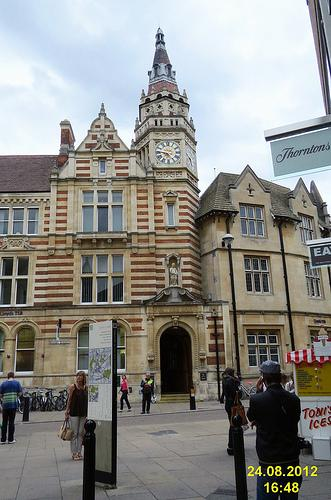What type of information would someone find on the map displayed on the sidewalk? The map offers explanations for tourists and directions around the town, helping them navigate and find various points of interest. What types of signs, stands, or kiosks can you identify in the image, and what are their characteristics? There is a red and white ice cream stand, a yellow time and date stamp, a sign giving directions around town, a kiosk selling assorted ices, and a sign advertising Thorntons in the image. Describe the scene on the sidewalk in front of the striped building, focusing on the people and their interactions. People are walking on the sidewalk, with a woman carrying a handbag, a man talking on a cell phone, and others engaging in conversations or observing their surroundings. Identify and describe the various color patterns and textures in the image, for both objects and architecture. The building features red and beige stripes, brown and tan bricks, and large grey stones make up the street. People are wearing colorful clothing, such as a blue and green shirt, a pink shirt, and grey pants. The ice cream stand has red and white colors, and bicycles have a mix of colors on their frames. What is happening around the base of the striped building, and what are people doing there? People are walking on the sidewalk near a line of bicycles parked outside the building, and a woman is carrying a brown purse while talking to a man on a cell phone. Mention the types of clothing that people are wearing and describe any unique patterns or styles. There's a man wearing a blue and green shirt with stripes in the middle, a woman wearing a pink shirt, a man wearing a hat, and a woman wearing a black tank top. Identify the primary focus of this image and describe it in detail. A tall striped building, red and beige in color, stands prominently with a clock tower at the top and a statue above the arched doorway. Provide an overview of various modes of transportation or items related to transportation in the image. There are bicycles parked near the building on the sidewalk, and a line of bikes outside the building indicates people using them for transportation. Describe the scene involving a woman and her handbag in the image. A woman wearing a pink shirt and grey pants is walking down the street, carrying a brown purse and looking slightly confused. Point out some specific architectural features of the old striped building. The building features a tall clock tower, red and beige stripes, an arched doorway, large windows, and a statue standing above the entrance. 